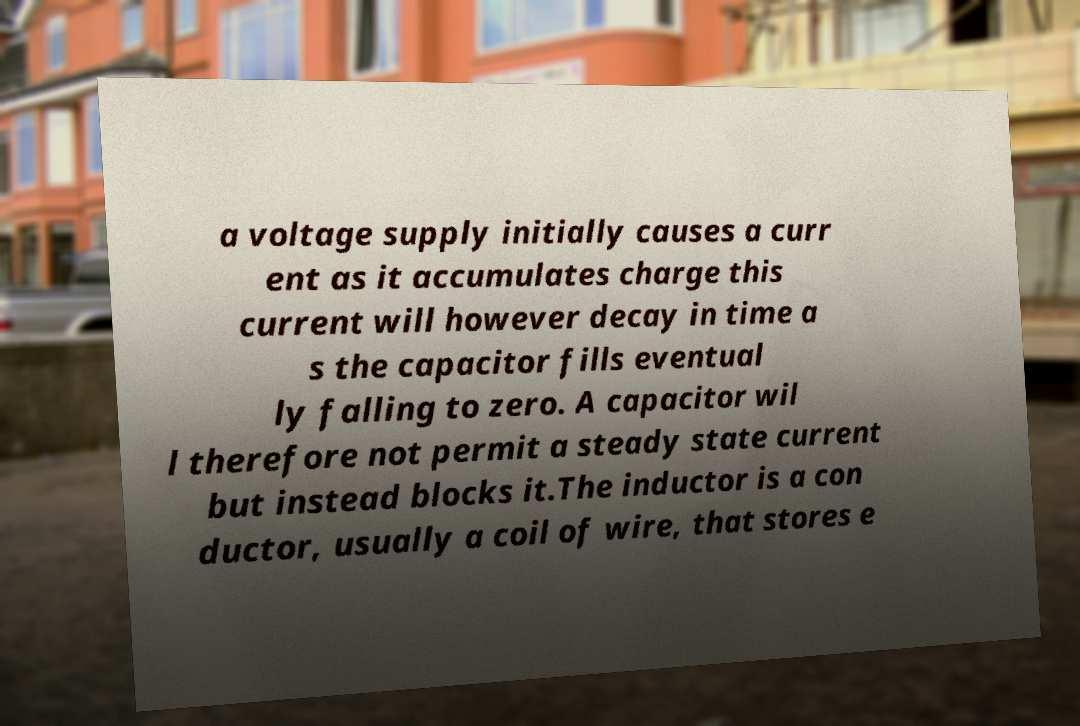Could you extract and type out the text from this image? a voltage supply initially causes a curr ent as it accumulates charge this current will however decay in time a s the capacitor fills eventual ly falling to zero. A capacitor wil l therefore not permit a steady state current but instead blocks it.The inductor is a con ductor, usually a coil of wire, that stores e 